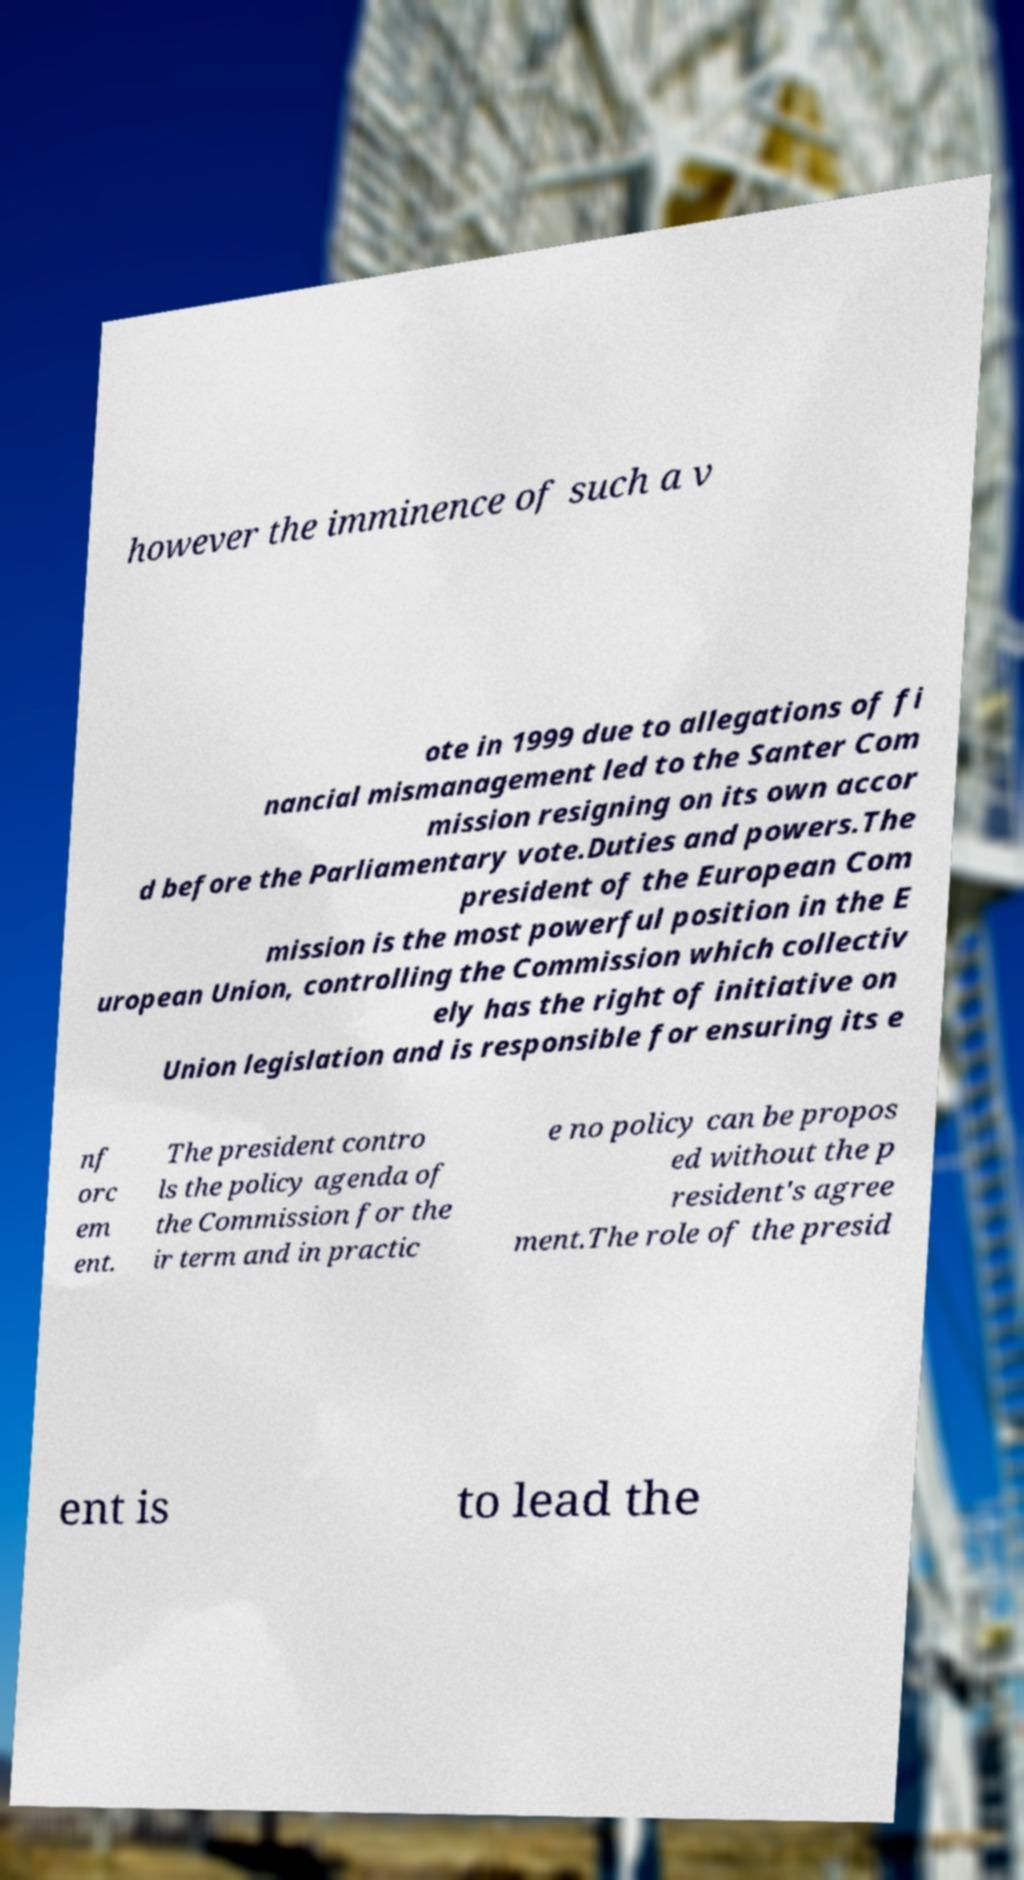Can you read and provide the text displayed in the image?This photo seems to have some interesting text. Can you extract and type it out for me? however the imminence of such a v ote in 1999 due to allegations of fi nancial mismanagement led to the Santer Com mission resigning on its own accor d before the Parliamentary vote.Duties and powers.The president of the European Com mission is the most powerful position in the E uropean Union, controlling the Commission which collectiv ely has the right of initiative on Union legislation and is responsible for ensuring its e nf orc em ent. The president contro ls the policy agenda of the Commission for the ir term and in practic e no policy can be propos ed without the p resident's agree ment.The role of the presid ent is to lead the 